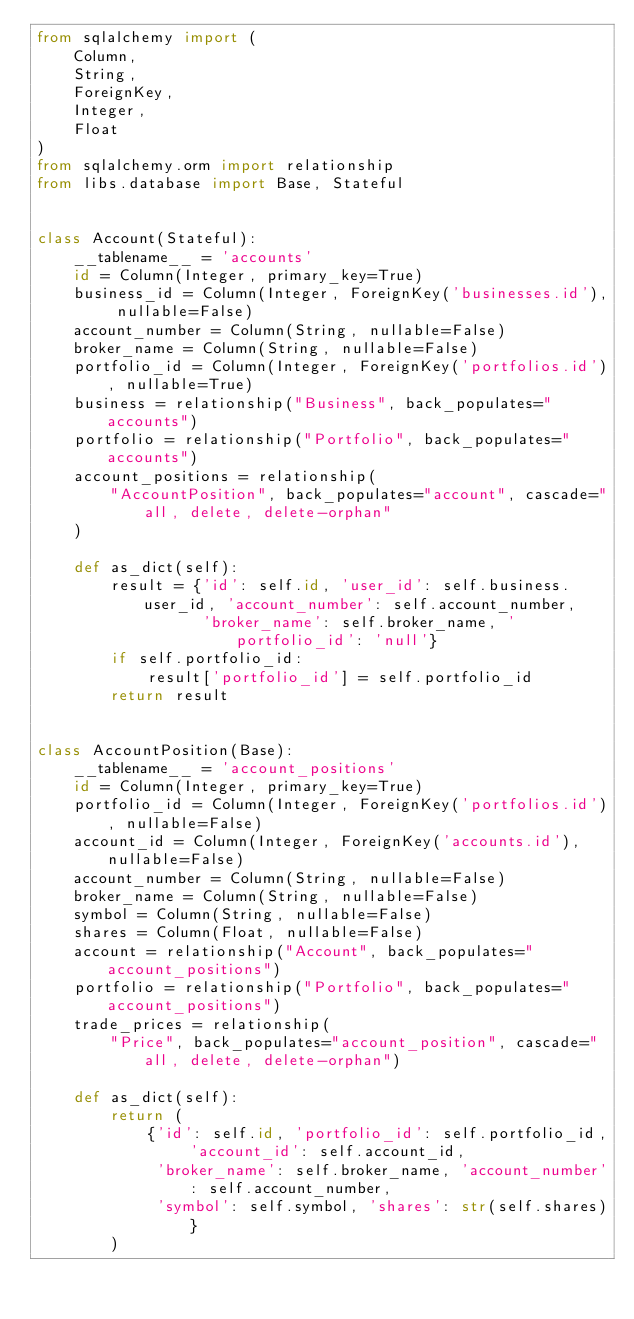<code> <loc_0><loc_0><loc_500><loc_500><_Python_>from sqlalchemy import (
    Column,
    String,
    ForeignKey,
    Integer,
    Float
)
from sqlalchemy.orm import relationship
from libs.database import Base, Stateful


class Account(Stateful):
    __tablename__ = 'accounts'
    id = Column(Integer, primary_key=True)
    business_id = Column(Integer, ForeignKey('businesses.id'), nullable=False)
    account_number = Column(String, nullable=False)
    broker_name = Column(String, nullable=False)
    portfolio_id = Column(Integer, ForeignKey('portfolios.id'), nullable=True)
    business = relationship("Business", back_populates="accounts")
    portfolio = relationship("Portfolio", back_populates="accounts")
    account_positions = relationship(
        "AccountPosition", back_populates="account", cascade="all, delete, delete-orphan"
    )

    def as_dict(self):
        result = {'id': self.id, 'user_id': self.business.user_id, 'account_number': self.account_number,
                  'broker_name': self.broker_name, 'portfolio_id': 'null'}
        if self.portfolio_id:
            result['portfolio_id'] = self.portfolio_id
        return result


class AccountPosition(Base):
    __tablename__ = 'account_positions'
    id = Column(Integer, primary_key=True)
    portfolio_id = Column(Integer, ForeignKey('portfolios.id'), nullable=False)
    account_id = Column(Integer, ForeignKey('accounts.id'), nullable=False)
    account_number = Column(String, nullable=False)
    broker_name = Column(String, nullable=False)
    symbol = Column(String, nullable=False)
    shares = Column(Float, nullable=False)
    account = relationship("Account", back_populates="account_positions")
    portfolio = relationship("Portfolio", back_populates="account_positions")
    trade_prices = relationship(
        "Price", back_populates="account_position", cascade="all, delete, delete-orphan")

    def as_dict(self):
        return (
            {'id': self.id, 'portfolio_id': self.portfolio_id, 'account_id': self.account_id,
             'broker_name': self.broker_name, 'account_number': self.account_number,
             'symbol': self.symbol, 'shares': str(self.shares)}
        )
</code> 